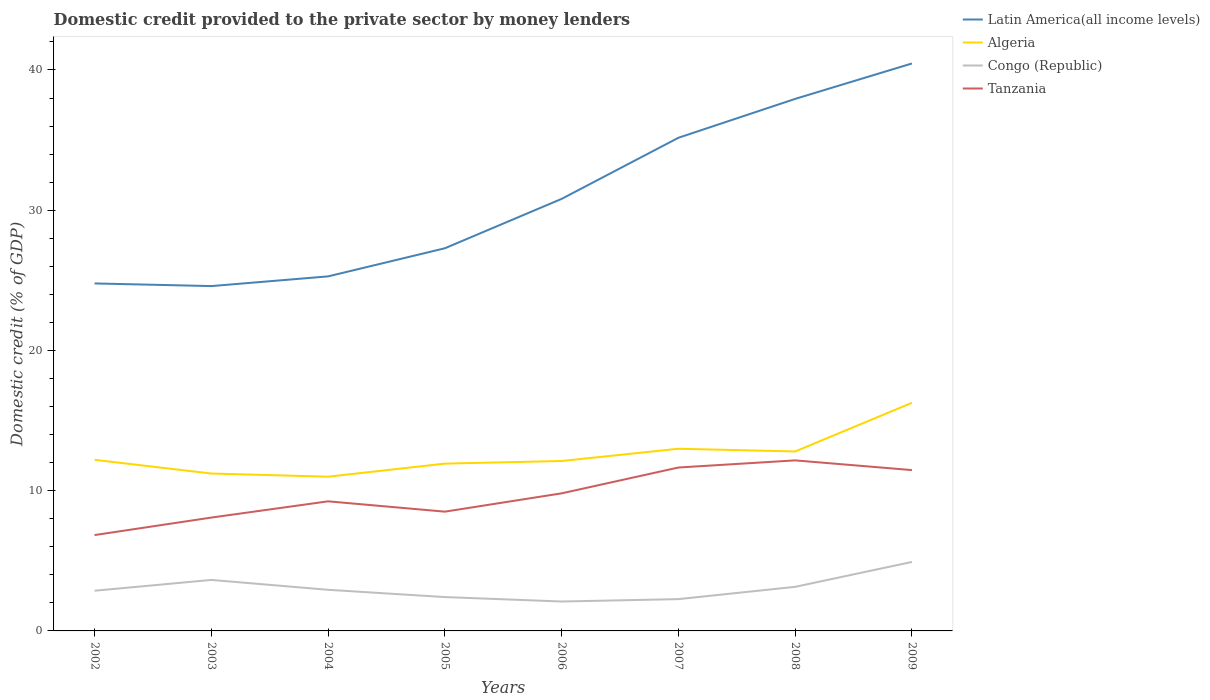Does the line corresponding to Tanzania intersect with the line corresponding to Latin America(all income levels)?
Offer a very short reply. No. Across all years, what is the maximum domestic credit provided to the private sector by money lenders in Congo (Republic)?
Provide a short and direct response. 2.1. In which year was the domestic credit provided to the private sector by money lenders in Tanzania maximum?
Ensure brevity in your answer.  2002. What is the total domestic credit provided to the private sector by money lenders in Latin America(all income levels) in the graph?
Provide a short and direct response. -0.69. What is the difference between the highest and the second highest domestic credit provided to the private sector by money lenders in Congo (Republic)?
Ensure brevity in your answer.  2.82. What is the difference between the highest and the lowest domestic credit provided to the private sector by money lenders in Congo (Republic)?
Offer a very short reply. 3. How many lines are there?
Ensure brevity in your answer.  4. What is the difference between two consecutive major ticks on the Y-axis?
Your answer should be very brief. 10. Does the graph contain any zero values?
Make the answer very short. No. Where does the legend appear in the graph?
Provide a short and direct response. Top right. How many legend labels are there?
Ensure brevity in your answer.  4. How are the legend labels stacked?
Keep it short and to the point. Vertical. What is the title of the graph?
Offer a very short reply. Domestic credit provided to the private sector by money lenders. What is the label or title of the Y-axis?
Provide a short and direct response. Domestic credit (% of GDP). What is the Domestic credit (% of GDP) in Latin America(all income levels) in 2002?
Provide a short and direct response. 24.78. What is the Domestic credit (% of GDP) of Algeria in 2002?
Provide a succinct answer. 12.2. What is the Domestic credit (% of GDP) in Congo (Republic) in 2002?
Offer a terse response. 2.87. What is the Domestic credit (% of GDP) in Tanzania in 2002?
Offer a very short reply. 6.83. What is the Domestic credit (% of GDP) of Latin America(all income levels) in 2003?
Offer a terse response. 24.59. What is the Domestic credit (% of GDP) in Algeria in 2003?
Your answer should be compact. 11.22. What is the Domestic credit (% of GDP) of Congo (Republic) in 2003?
Give a very brief answer. 3.64. What is the Domestic credit (% of GDP) of Tanzania in 2003?
Give a very brief answer. 8.08. What is the Domestic credit (% of GDP) of Latin America(all income levels) in 2004?
Provide a short and direct response. 25.28. What is the Domestic credit (% of GDP) in Algeria in 2004?
Make the answer very short. 11. What is the Domestic credit (% of GDP) of Congo (Republic) in 2004?
Your response must be concise. 2.93. What is the Domestic credit (% of GDP) of Tanzania in 2004?
Your answer should be very brief. 9.24. What is the Domestic credit (% of GDP) in Latin America(all income levels) in 2005?
Offer a very short reply. 27.29. What is the Domestic credit (% of GDP) in Algeria in 2005?
Keep it short and to the point. 11.93. What is the Domestic credit (% of GDP) in Congo (Republic) in 2005?
Your answer should be very brief. 2.41. What is the Domestic credit (% of GDP) of Tanzania in 2005?
Offer a very short reply. 8.5. What is the Domestic credit (% of GDP) of Latin America(all income levels) in 2006?
Give a very brief answer. 30.81. What is the Domestic credit (% of GDP) of Algeria in 2006?
Your answer should be compact. 12.12. What is the Domestic credit (% of GDP) in Congo (Republic) in 2006?
Provide a succinct answer. 2.1. What is the Domestic credit (% of GDP) of Tanzania in 2006?
Give a very brief answer. 9.81. What is the Domestic credit (% of GDP) of Latin America(all income levels) in 2007?
Offer a terse response. 35.16. What is the Domestic credit (% of GDP) in Algeria in 2007?
Offer a very short reply. 12.99. What is the Domestic credit (% of GDP) of Congo (Republic) in 2007?
Offer a terse response. 2.27. What is the Domestic credit (% of GDP) in Tanzania in 2007?
Provide a short and direct response. 11.65. What is the Domestic credit (% of GDP) in Latin America(all income levels) in 2008?
Offer a terse response. 37.94. What is the Domestic credit (% of GDP) of Algeria in 2008?
Offer a terse response. 12.8. What is the Domestic credit (% of GDP) of Congo (Republic) in 2008?
Keep it short and to the point. 3.14. What is the Domestic credit (% of GDP) of Tanzania in 2008?
Make the answer very short. 12.16. What is the Domestic credit (% of GDP) in Latin America(all income levels) in 2009?
Give a very brief answer. 40.46. What is the Domestic credit (% of GDP) in Algeria in 2009?
Give a very brief answer. 16.27. What is the Domestic credit (% of GDP) of Congo (Republic) in 2009?
Your answer should be compact. 4.92. What is the Domestic credit (% of GDP) in Tanzania in 2009?
Your answer should be compact. 11.47. Across all years, what is the maximum Domestic credit (% of GDP) of Latin America(all income levels)?
Ensure brevity in your answer.  40.46. Across all years, what is the maximum Domestic credit (% of GDP) of Algeria?
Your answer should be compact. 16.27. Across all years, what is the maximum Domestic credit (% of GDP) of Congo (Republic)?
Your answer should be compact. 4.92. Across all years, what is the maximum Domestic credit (% of GDP) in Tanzania?
Your answer should be very brief. 12.16. Across all years, what is the minimum Domestic credit (% of GDP) in Latin America(all income levels)?
Your response must be concise. 24.59. Across all years, what is the minimum Domestic credit (% of GDP) of Algeria?
Keep it short and to the point. 11. Across all years, what is the minimum Domestic credit (% of GDP) of Congo (Republic)?
Give a very brief answer. 2.1. Across all years, what is the minimum Domestic credit (% of GDP) of Tanzania?
Provide a succinct answer. 6.83. What is the total Domestic credit (% of GDP) of Latin America(all income levels) in the graph?
Give a very brief answer. 246.3. What is the total Domestic credit (% of GDP) of Algeria in the graph?
Offer a terse response. 100.52. What is the total Domestic credit (% of GDP) of Congo (Republic) in the graph?
Offer a very short reply. 24.28. What is the total Domestic credit (% of GDP) in Tanzania in the graph?
Your response must be concise. 77.75. What is the difference between the Domestic credit (% of GDP) of Latin America(all income levels) in 2002 and that in 2003?
Provide a succinct answer. 0.19. What is the difference between the Domestic credit (% of GDP) in Algeria in 2002 and that in 2003?
Keep it short and to the point. 0.98. What is the difference between the Domestic credit (% of GDP) of Congo (Republic) in 2002 and that in 2003?
Provide a short and direct response. -0.77. What is the difference between the Domestic credit (% of GDP) of Tanzania in 2002 and that in 2003?
Your answer should be very brief. -1.25. What is the difference between the Domestic credit (% of GDP) of Latin America(all income levels) in 2002 and that in 2004?
Provide a succinct answer. -0.5. What is the difference between the Domestic credit (% of GDP) of Algeria in 2002 and that in 2004?
Keep it short and to the point. 1.2. What is the difference between the Domestic credit (% of GDP) of Congo (Republic) in 2002 and that in 2004?
Your answer should be very brief. -0.07. What is the difference between the Domestic credit (% of GDP) in Tanzania in 2002 and that in 2004?
Make the answer very short. -2.41. What is the difference between the Domestic credit (% of GDP) of Latin America(all income levels) in 2002 and that in 2005?
Offer a terse response. -2.51. What is the difference between the Domestic credit (% of GDP) of Algeria in 2002 and that in 2005?
Make the answer very short. 0.27. What is the difference between the Domestic credit (% of GDP) in Congo (Republic) in 2002 and that in 2005?
Ensure brevity in your answer.  0.45. What is the difference between the Domestic credit (% of GDP) of Tanzania in 2002 and that in 2005?
Make the answer very short. -1.67. What is the difference between the Domestic credit (% of GDP) of Latin America(all income levels) in 2002 and that in 2006?
Offer a very short reply. -6.03. What is the difference between the Domestic credit (% of GDP) of Algeria in 2002 and that in 2006?
Provide a succinct answer. 0.08. What is the difference between the Domestic credit (% of GDP) of Congo (Republic) in 2002 and that in 2006?
Make the answer very short. 0.77. What is the difference between the Domestic credit (% of GDP) of Tanzania in 2002 and that in 2006?
Your answer should be compact. -2.98. What is the difference between the Domestic credit (% of GDP) in Latin America(all income levels) in 2002 and that in 2007?
Keep it short and to the point. -10.39. What is the difference between the Domestic credit (% of GDP) of Algeria in 2002 and that in 2007?
Offer a terse response. -0.79. What is the difference between the Domestic credit (% of GDP) of Congo (Republic) in 2002 and that in 2007?
Make the answer very short. 0.6. What is the difference between the Domestic credit (% of GDP) in Tanzania in 2002 and that in 2007?
Provide a succinct answer. -4.82. What is the difference between the Domestic credit (% of GDP) in Latin America(all income levels) in 2002 and that in 2008?
Keep it short and to the point. -13.16. What is the difference between the Domestic credit (% of GDP) of Algeria in 2002 and that in 2008?
Keep it short and to the point. -0.6. What is the difference between the Domestic credit (% of GDP) of Congo (Republic) in 2002 and that in 2008?
Provide a succinct answer. -0.28. What is the difference between the Domestic credit (% of GDP) in Tanzania in 2002 and that in 2008?
Offer a very short reply. -5.33. What is the difference between the Domestic credit (% of GDP) in Latin America(all income levels) in 2002 and that in 2009?
Make the answer very short. -15.68. What is the difference between the Domestic credit (% of GDP) in Algeria in 2002 and that in 2009?
Your answer should be compact. -4.07. What is the difference between the Domestic credit (% of GDP) of Congo (Republic) in 2002 and that in 2009?
Ensure brevity in your answer.  -2.05. What is the difference between the Domestic credit (% of GDP) in Tanzania in 2002 and that in 2009?
Your answer should be very brief. -4.63. What is the difference between the Domestic credit (% of GDP) in Latin America(all income levels) in 2003 and that in 2004?
Offer a terse response. -0.69. What is the difference between the Domestic credit (% of GDP) of Algeria in 2003 and that in 2004?
Offer a terse response. 0.22. What is the difference between the Domestic credit (% of GDP) of Congo (Republic) in 2003 and that in 2004?
Your answer should be very brief. 0.7. What is the difference between the Domestic credit (% of GDP) of Tanzania in 2003 and that in 2004?
Your answer should be very brief. -1.16. What is the difference between the Domestic credit (% of GDP) of Latin America(all income levels) in 2003 and that in 2005?
Keep it short and to the point. -2.7. What is the difference between the Domestic credit (% of GDP) in Algeria in 2003 and that in 2005?
Your answer should be very brief. -0.71. What is the difference between the Domestic credit (% of GDP) of Congo (Republic) in 2003 and that in 2005?
Offer a terse response. 1.22. What is the difference between the Domestic credit (% of GDP) of Tanzania in 2003 and that in 2005?
Keep it short and to the point. -0.42. What is the difference between the Domestic credit (% of GDP) of Latin America(all income levels) in 2003 and that in 2006?
Provide a short and direct response. -6.22. What is the difference between the Domestic credit (% of GDP) in Algeria in 2003 and that in 2006?
Make the answer very short. -0.89. What is the difference between the Domestic credit (% of GDP) in Congo (Republic) in 2003 and that in 2006?
Offer a very short reply. 1.54. What is the difference between the Domestic credit (% of GDP) of Tanzania in 2003 and that in 2006?
Give a very brief answer. -1.73. What is the difference between the Domestic credit (% of GDP) in Latin America(all income levels) in 2003 and that in 2007?
Your answer should be compact. -10.58. What is the difference between the Domestic credit (% of GDP) of Algeria in 2003 and that in 2007?
Your response must be concise. -1.77. What is the difference between the Domestic credit (% of GDP) of Congo (Republic) in 2003 and that in 2007?
Provide a succinct answer. 1.37. What is the difference between the Domestic credit (% of GDP) of Tanzania in 2003 and that in 2007?
Provide a short and direct response. -3.57. What is the difference between the Domestic credit (% of GDP) in Latin America(all income levels) in 2003 and that in 2008?
Your answer should be compact. -13.35. What is the difference between the Domestic credit (% of GDP) in Algeria in 2003 and that in 2008?
Provide a succinct answer. -1.57. What is the difference between the Domestic credit (% of GDP) in Congo (Republic) in 2003 and that in 2008?
Provide a succinct answer. 0.49. What is the difference between the Domestic credit (% of GDP) in Tanzania in 2003 and that in 2008?
Give a very brief answer. -4.08. What is the difference between the Domestic credit (% of GDP) in Latin America(all income levels) in 2003 and that in 2009?
Your answer should be compact. -15.87. What is the difference between the Domestic credit (% of GDP) of Algeria in 2003 and that in 2009?
Give a very brief answer. -5.04. What is the difference between the Domestic credit (% of GDP) of Congo (Republic) in 2003 and that in 2009?
Your answer should be very brief. -1.28. What is the difference between the Domestic credit (% of GDP) in Tanzania in 2003 and that in 2009?
Offer a very short reply. -3.38. What is the difference between the Domestic credit (% of GDP) in Latin America(all income levels) in 2004 and that in 2005?
Provide a succinct answer. -2. What is the difference between the Domestic credit (% of GDP) in Algeria in 2004 and that in 2005?
Your answer should be compact. -0.93. What is the difference between the Domestic credit (% of GDP) of Congo (Republic) in 2004 and that in 2005?
Provide a succinct answer. 0.52. What is the difference between the Domestic credit (% of GDP) of Tanzania in 2004 and that in 2005?
Provide a short and direct response. 0.74. What is the difference between the Domestic credit (% of GDP) in Latin America(all income levels) in 2004 and that in 2006?
Keep it short and to the point. -5.53. What is the difference between the Domestic credit (% of GDP) in Algeria in 2004 and that in 2006?
Offer a terse response. -1.12. What is the difference between the Domestic credit (% of GDP) of Congo (Republic) in 2004 and that in 2006?
Make the answer very short. 0.84. What is the difference between the Domestic credit (% of GDP) of Tanzania in 2004 and that in 2006?
Ensure brevity in your answer.  -0.57. What is the difference between the Domestic credit (% of GDP) of Latin America(all income levels) in 2004 and that in 2007?
Offer a terse response. -9.88. What is the difference between the Domestic credit (% of GDP) in Algeria in 2004 and that in 2007?
Your response must be concise. -1.99. What is the difference between the Domestic credit (% of GDP) in Congo (Republic) in 2004 and that in 2007?
Offer a terse response. 0.67. What is the difference between the Domestic credit (% of GDP) of Tanzania in 2004 and that in 2007?
Your response must be concise. -2.41. What is the difference between the Domestic credit (% of GDP) of Latin America(all income levels) in 2004 and that in 2008?
Give a very brief answer. -12.66. What is the difference between the Domestic credit (% of GDP) of Algeria in 2004 and that in 2008?
Offer a terse response. -1.8. What is the difference between the Domestic credit (% of GDP) of Congo (Republic) in 2004 and that in 2008?
Offer a terse response. -0.21. What is the difference between the Domestic credit (% of GDP) in Tanzania in 2004 and that in 2008?
Make the answer very short. -2.92. What is the difference between the Domestic credit (% of GDP) in Latin America(all income levels) in 2004 and that in 2009?
Your answer should be compact. -15.18. What is the difference between the Domestic credit (% of GDP) in Algeria in 2004 and that in 2009?
Offer a very short reply. -5.27. What is the difference between the Domestic credit (% of GDP) in Congo (Republic) in 2004 and that in 2009?
Provide a succinct answer. -1.99. What is the difference between the Domestic credit (% of GDP) of Tanzania in 2004 and that in 2009?
Provide a succinct answer. -2.23. What is the difference between the Domestic credit (% of GDP) of Latin America(all income levels) in 2005 and that in 2006?
Your response must be concise. -3.52. What is the difference between the Domestic credit (% of GDP) in Algeria in 2005 and that in 2006?
Give a very brief answer. -0.19. What is the difference between the Domestic credit (% of GDP) in Congo (Republic) in 2005 and that in 2006?
Provide a succinct answer. 0.32. What is the difference between the Domestic credit (% of GDP) in Tanzania in 2005 and that in 2006?
Provide a short and direct response. -1.31. What is the difference between the Domestic credit (% of GDP) in Latin America(all income levels) in 2005 and that in 2007?
Make the answer very short. -7.88. What is the difference between the Domestic credit (% of GDP) of Algeria in 2005 and that in 2007?
Offer a very short reply. -1.06. What is the difference between the Domestic credit (% of GDP) of Congo (Republic) in 2005 and that in 2007?
Your response must be concise. 0.15. What is the difference between the Domestic credit (% of GDP) in Tanzania in 2005 and that in 2007?
Provide a short and direct response. -3.15. What is the difference between the Domestic credit (% of GDP) of Latin America(all income levels) in 2005 and that in 2008?
Keep it short and to the point. -10.65. What is the difference between the Domestic credit (% of GDP) in Algeria in 2005 and that in 2008?
Offer a terse response. -0.87. What is the difference between the Domestic credit (% of GDP) in Congo (Republic) in 2005 and that in 2008?
Offer a very short reply. -0.73. What is the difference between the Domestic credit (% of GDP) of Tanzania in 2005 and that in 2008?
Your response must be concise. -3.66. What is the difference between the Domestic credit (% of GDP) of Latin America(all income levels) in 2005 and that in 2009?
Give a very brief answer. -13.18. What is the difference between the Domestic credit (% of GDP) in Algeria in 2005 and that in 2009?
Your response must be concise. -4.34. What is the difference between the Domestic credit (% of GDP) of Congo (Republic) in 2005 and that in 2009?
Your answer should be very brief. -2.5. What is the difference between the Domestic credit (% of GDP) in Tanzania in 2005 and that in 2009?
Provide a short and direct response. -2.96. What is the difference between the Domestic credit (% of GDP) in Latin America(all income levels) in 2006 and that in 2007?
Your answer should be very brief. -4.36. What is the difference between the Domestic credit (% of GDP) of Algeria in 2006 and that in 2007?
Provide a succinct answer. -0.87. What is the difference between the Domestic credit (% of GDP) of Congo (Republic) in 2006 and that in 2007?
Make the answer very short. -0.17. What is the difference between the Domestic credit (% of GDP) of Tanzania in 2006 and that in 2007?
Offer a very short reply. -1.84. What is the difference between the Domestic credit (% of GDP) of Latin America(all income levels) in 2006 and that in 2008?
Offer a terse response. -7.13. What is the difference between the Domestic credit (% of GDP) of Algeria in 2006 and that in 2008?
Give a very brief answer. -0.68. What is the difference between the Domestic credit (% of GDP) of Congo (Republic) in 2006 and that in 2008?
Give a very brief answer. -1.05. What is the difference between the Domestic credit (% of GDP) in Tanzania in 2006 and that in 2008?
Provide a succinct answer. -2.35. What is the difference between the Domestic credit (% of GDP) in Latin America(all income levels) in 2006 and that in 2009?
Give a very brief answer. -9.65. What is the difference between the Domestic credit (% of GDP) in Algeria in 2006 and that in 2009?
Your response must be concise. -4.15. What is the difference between the Domestic credit (% of GDP) of Congo (Republic) in 2006 and that in 2009?
Offer a very short reply. -2.82. What is the difference between the Domestic credit (% of GDP) of Tanzania in 2006 and that in 2009?
Keep it short and to the point. -1.66. What is the difference between the Domestic credit (% of GDP) in Latin America(all income levels) in 2007 and that in 2008?
Your answer should be very brief. -2.77. What is the difference between the Domestic credit (% of GDP) in Algeria in 2007 and that in 2008?
Offer a very short reply. 0.19. What is the difference between the Domestic credit (% of GDP) of Congo (Republic) in 2007 and that in 2008?
Your answer should be compact. -0.88. What is the difference between the Domestic credit (% of GDP) of Tanzania in 2007 and that in 2008?
Your answer should be compact. -0.51. What is the difference between the Domestic credit (% of GDP) in Latin America(all income levels) in 2007 and that in 2009?
Keep it short and to the point. -5.3. What is the difference between the Domestic credit (% of GDP) in Algeria in 2007 and that in 2009?
Offer a very short reply. -3.28. What is the difference between the Domestic credit (% of GDP) in Congo (Republic) in 2007 and that in 2009?
Your response must be concise. -2.65. What is the difference between the Domestic credit (% of GDP) of Tanzania in 2007 and that in 2009?
Offer a very short reply. 0.18. What is the difference between the Domestic credit (% of GDP) of Latin America(all income levels) in 2008 and that in 2009?
Your answer should be very brief. -2.53. What is the difference between the Domestic credit (% of GDP) of Algeria in 2008 and that in 2009?
Offer a terse response. -3.47. What is the difference between the Domestic credit (% of GDP) of Congo (Republic) in 2008 and that in 2009?
Offer a very short reply. -1.77. What is the difference between the Domestic credit (% of GDP) in Tanzania in 2008 and that in 2009?
Ensure brevity in your answer.  0.69. What is the difference between the Domestic credit (% of GDP) of Latin America(all income levels) in 2002 and the Domestic credit (% of GDP) of Algeria in 2003?
Provide a short and direct response. 13.55. What is the difference between the Domestic credit (% of GDP) in Latin America(all income levels) in 2002 and the Domestic credit (% of GDP) in Congo (Republic) in 2003?
Provide a succinct answer. 21.14. What is the difference between the Domestic credit (% of GDP) of Latin America(all income levels) in 2002 and the Domestic credit (% of GDP) of Tanzania in 2003?
Your answer should be very brief. 16.69. What is the difference between the Domestic credit (% of GDP) in Algeria in 2002 and the Domestic credit (% of GDP) in Congo (Republic) in 2003?
Your response must be concise. 8.56. What is the difference between the Domestic credit (% of GDP) in Algeria in 2002 and the Domestic credit (% of GDP) in Tanzania in 2003?
Provide a short and direct response. 4.12. What is the difference between the Domestic credit (% of GDP) of Congo (Republic) in 2002 and the Domestic credit (% of GDP) of Tanzania in 2003?
Your response must be concise. -5.22. What is the difference between the Domestic credit (% of GDP) of Latin America(all income levels) in 2002 and the Domestic credit (% of GDP) of Algeria in 2004?
Make the answer very short. 13.78. What is the difference between the Domestic credit (% of GDP) of Latin America(all income levels) in 2002 and the Domestic credit (% of GDP) of Congo (Republic) in 2004?
Ensure brevity in your answer.  21.84. What is the difference between the Domestic credit (% of GDP) of Latin America(all income levels) in 2002 and the Domestic credit (% of GDP) of Tanzania in 2004?
Your answer should be very brief. 15.54. What is the difference between the Domestic credit (% of GDP) in Algeria in 2002 and the Domestic credit (% of GDP) in Congo (Republic) in 2004?
Give a very brief answer. 9.27. What is the difference between the Domestic credit (% of GDP) in Algeria in 2002 and the Domestic credit (% of GDP) in Tanzania in 2004?
Offer a terse response. 2.96. What is the difference between the Domestic credit (% of GDP) in Congo (Republic) in 2002 and the Domestic credit (% of GDP) in Tanzania in 2004?
Offer a terse response. -6.37. What is the difference between the Domestic credit (% of GDP) of Latin America(all income levels) in 2002 and the Domestic credit (% of GDP) of Algeria in 2005?
Provide a short and direct response. 12.85. What is the difference between the Domestic credit (% of GDP) in Latin America(all income levels) in 2002 and the Domestic credit (% of GDP) in Congo (Republic) in 2005?
Make the answer very short. 22.36. What is the difference between the Domestic credit (% of GDP) in Latin America(all income levels) in 2002 and the Domestic credit (% of GDP) in Tanzania in 2005?
Make the answer very short. 16.27. What is the difference between the Domestic credit (% of GDP) in Algeria in 2002 and the Domestic credit (% of GDP) in Congo (Republic) in 2005?
Ensure brevity in your answer.  9.79. What is the difference between the Domestic credit (% of GDP) in Algeria in 2002 and the Domestic credit (% of GDP) in Tanzania in 2005?
Make the answer very short. 3.7. What is the difference between the Domestic credit (% of GDP) in Congo (Republic) in 2002 and the Domestic credit (% of GDP) in Tanzania in 2005?
Provide a succinct answer. -5.64. What is the difference between the Domestic credit (% of GDP) in Latin America(all income levels) in 2002 and the Domestic credit (% of GDP) in Algeria in 2006?
Provide a succinct answer. 12.66. What is the difference between the Domestic credit (% of GDP) of Latin America(all income levels) in 2002 and the Domestic credit (% of GDP) of Congo (Republic) in 2006?
Ensure brevity in your answer.  22.68. What is the difference between the Domestic credit (% of GDP) in Latin America(all income levels) in 2002 and the Domestic credit (% of GDP) in Tanzania in 2006?
Provide a short and direct response. 14.97. What is the difference between the Domestic credit (% of GDP) of Algeria in 2002 and the Domestic credit (% of GDP) of Congo (Republic) in 2006?
Provide a succinct answer. 10.1. What is the difference between the Domestic credit (% of GDP) of Algeria in 2002 and the Domestic credit (% of GDP) of Tanzania in 2006?
Your answer should be very brief. 2.39. What is the difference between the Domestic credit (% of GDP) of Congo (Republic) in 2002 and the Domestic credit (% of GDP) of Tanzania in 2006?
Give a very brief answer. -6.94. What is the difference between the Domestic credit (% of GDP) in Latin America(all income levels) in 2002 and the Domestic credit (% of GDP) in Algeria in 2007?
Provide a short and direct response. 11.79. What is the difference between the Domestic credit (% of GDP) in Latin America(all income levels) in 2002 and the Domestic credit (% of GDP) in Congo (Republic) in 2007?
Keep it short and to the point. 22.51. What is the difference between the Domestic credit (% of GDP) of Latin America(all income levels) in 2002 and the Domestic credit (% of GDP) of Tanzania in 2007?
Your answer should be very brief. 13.13. What is the difference between the Domestic credit (% of GDP) of Algeria in 2002 and the Domestic credit (% of GDP) of Congo (Republic) in 2007?
Provide a succinct answer. 9.93. What is the difference between the Domestic credit (% of GDP) in Algeria in 2002 and the Domestic credit (% of GDP) in Tanzania in 2007?
Provide a short and direct response. 0.55. What is the difference between the Domestic credit (% of GDP) of Congo (Republic) in 2002 and the Domestic credit (% of GDP) of Tanzania in 2007?
Offer a terse response. -8.79. What is the difference between the Domestic credit (% of GDP) in Latin America(all income levels) in 2002 and the Domestic credit (% of GDP) in Algeria in 2008?
Provide a succinct answer. 11.98. What is the difference between the Domestic credit (% of GDP) of Latin America(all income levels) in 2002 and the Domestic credit (% of GDP) of Congo (Republic) in 2008?
Your response must be concise. 21.63. What is the difference between the Domestic credit (% of GDP) of Latin America(all income levels) in 2002 and the Domestic credit (% of GDP) of Tanzania in 2008?
Ensure brevity in your answer.  12.62. What is the difference between the Domestic credit (% of GDP) in Algeria in 2002 and the Domestic credit (% of GDP) in Congo (Republic) in 2008?
Your answer should be compact. 9.06. What is the difference between the Domestic credit (% of GDP) in Algeria in 2002 and the Domestic credit (% of GDP) in Tanzania in 2008?
Offer a terse response. 0.04. What is the difference between the Domestic credit (% of GDP) of Congo (Republic) in 2002 and the Domestic credit (% of GDP) of Tanzania in 2008?
Offer a terse response. -9.29. What is the difference between the Domestic credit (% of GDP) in Latin America(all income levels) in 2002 and the Domestic credit (% of GDP) in Algeria in 2009?
Your answer should be very brief. 8.51. What is the difference between the Domestic credit (% of GDP) in Latin America(all income levels) in 2002 and the Domestic credit (% of GDP) in Congo (Republic) in 2009?
Offer a terse response. 19.86. What is the difference between the Domestic credit (% of GDP) in Latin America(all income levels) in 2002 and the Domestic credit (% of GDP) in Tanzania in 2009?
Offer a terse response. 13.31. What is the difference between the Domestic credit (% of GDP) of Algeria in 2002 and the Domestic credit (% of GDP) of Congo (Republic) in 2009?
Ensure brevity in your answer.  7.28. What is the difference between the Domestic credit (% of GDP) of Algeria in 2002 and the Domestic credit (% of GDP) of Tanzania in 2009?
Make the answer very short. 0.73. What is the difference between the Domestic credit (% of GDP) of Congo (Republic) in 2002 and the Domestic credit (% of GDP) of Tanzania in 2009?
Provide a succinct answer. -8.6. What is the difference between the Domestic credit (% of GDP) of Latin America(all income levels) in 2003 and the Domestic credit (% of GDP) of Algeria in 2004?
Make the answer very short. 13.59. What is the difference between the Domestic credit (% of GDP) in Latin America(all income levels) in 2003 and the Domestic credit (% of GDP) in Congo (Republic) in 2004?
Keep it short and to the point. 21.66. What is the difference between the Domestic credit (% of GDP) of Latin America(all income levels) in 2003 and the Domestic credit (% of GDP) of Tanzania in 2004?
Offer a very short reply. 15.35. What is the difference between the Domestic credit (% of GDP) in Algeria in 2003 and the Domestic credit (% of GDP) in Congo (Republic) in 2004?
Offer a very short reply. 8.29. What is the difference between the Domestic credit (% of GDP) of Algeria in 2003 and the Domestic credit (% of GDP) of Tanzania in 2004?
Your answer should be very brief. 1.98. What is the difference between the Domestic credit (% of GDP) in Congo (Republic) in 2003 and the Domestic credit (% of GDP) in Tanzania in 2004?
Your response must be concise. -5.6. What is the difference between the Domestic credit (% of GDP) in Latin America(all income levels) in 2003 and the Domestic credit (% of GDP) in Algeria in 2005?
Give a very brief answer. 12.66. What is the difference between the Domestic credit (% of GDP) of Latin America(all income levels) in 2003 and the Domestic credit (% of GDP) of Congo (Republic) in 2005?
Your response must be concise. 22.17. What is the difference between the Domestic credit (% of GDP) in Latin America(all income levels) in 2003 and the Domestic credit (% of GDP) in Tanzania in 2005?
Provide a succinct answer. 16.08. What is the difference between the Domestic credit (% of GDP) of Algeria in 2003 and the Domestic credit (% of GDP) of Congo (Republic) in 2005?
Your answer should be compact. 8.81. What is the difference between the Domestic credit (% of GDP) in Algeria in 2003 and the Domestic credit (% of GDP) in Tanzania in 2005?
Provide a succinct answer. 2.72. What is the difference between the Domestic credit (% of GDP) in Congo (Republic) in 2003 and the Domestic credit (% of GDP) in Tanzania in 2005?
Keep it short and to the point. -4.87. What is the difference between the Domestic credit (% of GDP) in Latin America(all income levels) in 2003 and the Domestic credit (% of GDP) in Algeria in 2006?
Keep it short and to the point. 12.47. What is the difference between the Domestic credit (% of GDP) of Latin America(all income levels) in 2003 and the Domestic credit (% of GDP) of Congo (Republic) in 2006?
Provide a succinct answer. 22.49. What is the difference between the Domestic credit (% of GDP) in Latin America(all income levels) in 2003 and the Domestic credit (% of GDP) in Tanzania in 2006?
Keep it short and to the point. 14.78. What is the difference between the Domestic credit (% of GDP) of Algeria in 2003 and the Domestic credit (% of GDP) of Congo (Republic) in 2006?
Provide a short and direct response. 9.13. What is the difference between the Domestic credit (% of GDP) in Algeria in 2003 and the Domestic credit (% of GDP) in Tanzania in 2006?
Make the answer very short. 1.41. What is the difference between the Domestic credit (% of GDP) in Congo (Republic) in 2003 and the Domestic credit (% of GDP) in Tanzania in 2006?
Your response must be concise. -6.17. What is the difference between the Domestic credit (% of GDP) in Latin America(all income levels) in 2003 and the Domestic credit (% of GDP) in Algeria in 2007?
Offer a terse response. 11.6. What is the difference between the Domestic credit (% of GDP) in Latin America(all income levels) in 2003 and the Domestic credit (% of GDP) in Congo (Republic) in 2007?
Provide a short and direct response. 22.32. What is the difference between the Domestic credit (% of GDP) in Latin America(all income levels) in 2003 and the Domestic credit (% of GDP) in Tanzania in 2007?
Offer a terse response. 12.94. What is the difference between the Domestic credit (% of GDP) of Algeria in 2003 and the Domestic credit (% of GDP) of Congo (Republic) in 2007?
Keep it short and to the point. 8.96. What is the difference between the Domestic credit (% of GDP) in Algeria in 2003 and the Domestic credit (% of GDP) in Tanzania in 2007?
Provide a short and direct response. -0.43. What is the difference between the Domestic credit (% of GDP) in Congo (Republic) in 2003 and the Domestic credit (% of GDP) in Tanzania in 2007?
Your answer should be compact. -8.02. What is the difference between the Domestic credit (% of GDP) of Latin America(all income levels) in 2003 and the Domestic credit (% of GDP) of Algeria in 2008?
Your answer should be very brief. 11.79. What is the difference between the Domestic credit (% of GDP) of Latin America(all income levels) in 2003 and the Domestic credit (% of GDP) of Congo (Republic) in 2008?
Your response must be concise. 21.44. What is the difference between the Domestic credit (% of GDP) in Latin America(all income levels) in 2003 and the Domestic credit (% of GDP) in Tanzania in 2008?
Make the answer very short. 12.43. What is the difference between the Domestic credit (% of GDP) of Algeria in 2003 and the Domestic credit (% of GDP) of Congo (Republic) in 2008?
Offer a terse response. 8.08. What is the difference between the Domestic credit (% of GDP) of Algeria in 2003 and the Domestic credit (% of GDP) of Tanzania in 2008?
Provide a succinct answer. -0.94. What is the difference between the Domestic credit (% of GDP) in Congo (Republic) in 2003 and the Domestic credit (% of GDP) in Tanzania in 2008?
Provide a short and direct response. -8.52. What is the difference between the Domestic credit (% of GDP) in Latin America(all income levels) in 2003 and the Domestic credit (% of GDP) in Algeria in 2009?
Offer a very short reply. 8.32. What is the difference between the Domestic credit (% of GDP) in Latin America(all income levels) in 2003 and the Domestic credit (% of GDP) in Congo (Republic) in 2009?
Your response must be concise. 19.67. What is the difference between the Domestic credit (% of GDP) in Latin America(all income levels) in 2003 and the Domestic credit (% of GDP) in Tanzania in 2009?
Keep it short and to the point. 13.12. What is the difference between the Domestic credit (% of GDP) of Algeria in 2003 and the Domestic credit (% of GDP) of Congo (Republic) in 2009?
Make the answer very short. 6.3. What is the difference between the Domestic credit (% of GDP) in Algeria in 2003 and the Domestic credit (% of GDP) in Tanzania in 2009?
Provide a short and direct response. -0.25. What is the difference between the Domestic credit (% of GDP) of Congo (Republic) in 2003 and the Domestic credit (% of GDP) of Tanzania in 2009?
Your response must be concise. -7.83. What is the difference between the Domestic credit (% of GDP) in Latin America(all income levels) in 2004 and the Domestic credit (% of GDP) in Algeria in 2005?
Offer a very short reply. 13.35. What is the difference between the Domestic credit (% of GDP) of Latin America(all income levels) in 2004 and the Domestic credit (% of GDP) of Congo (Republic) in 2005?
Make the answer very short. 22.87. What is the difference between the Domestic credit (% of GDP) of Latin America(all income levels) in 2004 and the Domestic credit (% of GDP) of Tanzania in 2005?
Give a very brief answer. 16.78. What is the difference between the Domestic credit (% of GDP) of Algeria in 2004 and the Domestic credit (% of GDP) of Congo (Republic) in 2005?
Your answer should be very brief. 8.58. What is the difference between the Domestic credit (% of GDP) of Algeria in 2004 and the Domestic credit (% of GDP) of Tanzania in 2005?
Your response must be concise. 2.49. What is the difference between the Domestic credit (% of GDP) of Congo (Republic) in 2004 and the Domestic credit (% of GDP) of Tanzania in 2005?
Ensure brevity in your answer.  -5.57. What is the difference between the Domestic credit (% of GDP) in Latin America(all income levels) in 2004 and the Domestic credit (% of GDP) in Algeria in 2006?
Ensure brevity in your answer.  13.16. What is the difference between the Domestic credit (% of GDP) of Latin America(all income levels) in 2004 and the Domestic credit (% of GDP) of Congo (Republic) in 2006?
Provide a short and direct response. 23.18. What is the difference between the Domestic credit (% of GDP) of Latin America(all income levels) in 2004 and the Domestic credit (% of GDP) of Tanzania in 2006?
Keep it short and to the point. 15.47. What is the difference between the Domestic credit (% of GDP) in Algeria in 2004 and the Domestic credit (% of GDP) in Congo (Republic) in 2006?
Make the answer very short. 8.9. What is the difference between the Domestic credit (% of GDP) of Algeria in 2004 and the Domestic credit (% of GDP) of Tanzania in 2006?
Provide a short and direct response. 1.19. What is the difference between the Domestic credit (% of GDP) in Congo (Republic) in 2004 and the Domestic credit (% of GDP) in Tanzania in 2006?
Provide a succinct answer. -6.88. What is the difference between the Domestic credit (% of GDP) of Latin America(all income levels) in 2004 and the Domestic credit (% of GDP) of Algeria in 2007?
Your answer should be compact. 12.29. What is the difference between the Domestic credit (% of GDP) of Latin America(all income levels) in 2004 and the Domestic credit (% of GDP) of Congo (Republic) in 2007?
Ensure brevity in your answer.  23.01. What is the difference between the Domestic credit (% of GDP) in Latin America(all income levels) in 2004 and the Domestic credit (% of GDP) in Tanzania in 2007?
Keep it short and to the point. 13.63. What is the difference between the Domestic credit (% of GDP) of Algeria in 2004 and the Domestic credit (% of GDP) of Congo (Republic) in 2007?
Offer a very short reply. 8.73. What is the difference between the Domestic credit (% of GDP) of Algeria in 2004 and the Domestic credit (% of GDP) of Tanzania in 2007?
Give a very brief answer. -0.65. What is the difference between the Domestic credit (% of GDP) of Congo (Republic) in 2004 and the Domestic credit (% of GDP) of Tanzania in 2007?
Provide a short and direct response. -8.72. What is the difference between the Domestic credit (% of GDP) in Latin America(all income levels) in 2004 and the Domestic credit (% of GDP) in Algeria in 2008?
Your answer should be very brief. 12.49. What is the difference between the Domestic credit (% of GDP) in Latin America(all income levels) in 2004 and the Domestic credit (% of GDP) in Congo (Republic) in 2008?
Your answer should be very brief. 22.14. What is the difference between the Domestic credit (% of GDP) in Latin America(all income levels) in 2004 and the Domestic credit (% of GDP) in Tanzania in 2008?
Keep it short and to the point. 13.12. What is the difference between the Domestic credit (% of GDP) in Algeria in 2004 and the Domestic credit (% of GDP) in Congo (Republic) in 2008?
Keep it short and to the point. 7.85. What is the difference between the Domestic credit (% of GDP) of Algeria in 2004 and the Domestic credit (% of GDP) of Tanzania in 2008?
Offer a terse response. -1.16. What is the difference between the Domestic credit (% of GDP) of Congo (Republic) in 2004 and the Domestic credit (% of GDP) of Tanzania in 2008?
Offer a very short reply. -9.23. What is the difference between the Domestic credit (% of GDP) in Latin America(all income levels) in 2004 and the Domestic credit (% of GDP) in Algeria in 2009?
Offer a terse response. 9.02. What is the difference between the Domestic credit (% of GDP) of Latin America(all income levels) in 2004 and the Domestic credit (% of GDP) of Congo (Republic) in 2009?
Ensure brevity in your answer.  20.36. What is the difference between the Domestic credit (% of GDP) in Latin America(all income levels) in 2004 and the Domestic credit (% of GDP) in Tanzania in 2009?
Give a very brief answer. 13.81. What is the difference between the Domestic credit (% of GDP) in Algeria in 2004 and the Domestic credit (% of GDP) in Congo (Republic) in 2009?
Your answer should be very brief. 6.08. What is the difference between the Domestic credit (% of GDP) in Algeria in 2004 and the Domestic credit (% of GDP) in Tanzania in 2009?
Give a very brief answer. -0.47. What is the difference between the Domestic credit (% of GDP) in Congo (Republic) in 2004 and the Domestic credit (% of GDP) in Tanzania in 2009?
Give a very brief answer. -8.53. What is the difference between the Domestic credit (% of GDP) of Latin America(all income levels) in 2005 and the Domestic credit (% of GDP) of Algeria in 2006?
Ensure brevity in your answer.  15.17. What is the difference between the Domestic credit (% of GDP) in Latin America(all income levels) in 2005 and the Domestic credit (% of GDP) in Congo (Republic) in 2006?
Your response must be concise. 25.19. What is the difference between the Domestic credit (% of GDP) of Latin America(all income levels) in 2005 and the Domestic credit (% of GDP) of Tanzania in 2006?
Your response must be concise. 17.47. What is the difference between the Domestic credit (% of GDP) in Algeria in 2005 and the Domestic credit (% of GDP) in Congo (Republic) in 2006?
Make the answer very short. 9.83. What is the difference between the Domestic credit (% of GDP) in Algeria in 2005 and the Domestic credit (% of GDP) in Tanzania in 2006?
Offer a very short reply. 2.12. What is the difference between the Domestic credit (% of GDP) of Congo (Republic) in 2005 and the Domestic credit (% of GDP) of Tanzania in 2006?
Give a very brief answer. -7.4. What is the difference between the Domestic credit (% of GDP) of Latin America(all income levels) in 2005 and the Domestic credit (% of GDP) of Algeria in 2007?
Keep it short and to the point. 14.3. What is the difference between the Domestic credit (% of GDP) in Latin America(all income levels) in 2005 and the Domestic credit (% of GDP) in Congo (Republic) in 2007?
Provide a succinct answer. 25.02. What is the difference between the Domestic credit (% of GDP) of Latin America(all income levels) in 2005 and the Domestic credit (% of GDP) of Tanzania in 2007?
Your answer should be very brief. 15.63. What is the difference between the Domestic credit (% of GDP) in Algeria in 2005 and the Domestic credit (% of GDP) in Congo (Republic) in 2007?
Your response must be concise. 9.66. What is the difference between the Domestic credit (% of GDP) of Algeria in 2005 and the Domestic credit (% of GDP) of Tanzania in 2007?
Keep it short and to the point. 0.28. What is the difference between the Domestic credit (% of GDP) in Congo (Republic) in 2005 and the Domestic credit (% of GDP) in Tanzania in 2007?
Provide a succinct answer. -9.24. What is the difference between the Domestic credit (% of GDP) of Latin America(all income levels) in 2005 and the Domestic credit (% of GDP) of Algeria in 2008?
Your answer should be compact. 14.49. What is the difference between the Domestic credit (% of GDP) in Latin America(all income levels) in 2005 and the Domestic credit (% of GDP) in Congo (Republic) in 2008?
Offer a very short reply. 24.14. What is the difference between the Domestic credit (% of GDP) of Latin America(all income levels) in 2005 and the Domestic credit (% of GDP) of Tanzania in 2008?
Provide a succinct answer. 15.12. What is the difference between the Domestic credit (% of GDP) in Algeria in 2005 and the Domestic credit (% of GDP) in Congo (Republic) in 2008?
Offer a terse response. 8.79. What is the difference between the Domestic credit (% of GDP) of Algeria in 2005 and the Domestic credit (% of GDP) of Tanzania in 2008?
Ensure brevity in your answer.  -0.23. What is the difference between the Domestic credit (% of GDP) in Congo (Republic) in 2005 and the Domestic credit (% of GDP) in Tanzania in 2008?
Your answer should be compact. -9.75. What is the difference between the Domestic credit (% of GDP) of Latin America(all income levels) in 2005 and the Domestic credit (% of GDP) of Algeria in 2009?
Offer a very short reply. 11.02. What is the difference between the Domestic credit (% of GDP) of Latin America(all income levels) in 2005 and the Domestic credit (% of GDP) of Congo (Republic) in 2009?
Your answer should be very brief. 22.37. What is the difference between the Domestic credit (% of GDP) in Latin America(all income levels) in 2005 and the Domestic credit (% of GDP) in Tanzania in 2009?
Your response must be concise. 15.82. What is the difference between the Domestic credit (% of GDP) in Algeria in 2005 and the Domestic credit (% of GDP) in Congo (Republic) in 2009?
Your answer should be compact. 7.01. What is the difference between the Domestic credit (% of GDP) of Algeria in 2005 and the Domestic credit (% of GDP) of Tanzania in 2009?
Make the answer very short. 0.46. What is the difference between the Domestic credit (% of GDP) of Congo (Republic) in 2005 and the Domestic credit (% of GDP) of Tanzania in 2009?
Make the answer very short. -9.05. What is the difference between the Domestic credit (% of GDP) of Latin America(all income levels) in 2006 and the Domestic credit (% of GDP) of Algeria in 2007?
Keep it short and to the point. 17.82. What is the difference between the Domestic credit (% of GDP) of Latin America(all income levels) in 2006 and the Domestic credit (% of GDP) of Congo (Republic) in 2007?
Make the answer very short. 28.54. What is the difference between the Domestic credit (% of GDP) of Latin America(all income levels) in 2006 and the Domestic credit (% of GDP) of Tanzania in 2007?
Offer a very short reply. 19.16. What is the difference between the Domestic credit (% of GDP) in Algeria in 2006 and the Domestic credit (% of GDP) in Congo (Republic) in 2007?
Keep it short and to the point. 9.85. What is the difference between the Domestic credit (% of GDP) of Algeria in 2006 and the Domestic credit (% of GDP) of Tanzania in 2007?
Offer a terse response. 0.47. What is the difference between the Domestic credit (% of GDP) of Congo (Republic) in 2006 and the Domestic credit (% of GDP) of Tanzania in 2007?
Provide a short and direct response. -9.55. What is the difference between the Domestic credit (% of GDP) in Latin America(all income levels) in 2006 and the Domestic credit (% of GDP) in Algeria in 2008?
Provide a succinct answer. 18.01. What is the difference between the Domestic credit (% of GDP) of Latin America(all income levels) in 2006 and the Domestic credit (% of GDP) of Congo (Republic) in 2008?
Your response must be concise. 27.66. What is the difference between the Domestic credit (% of GDP) in Latin America(all income levels) in 2006 and the Domestic credit (% of GDP) in Tanzania in 2008?
Make the answer very short. 18.65. What is the difference between the Domestic credit (% of GDP) of Algeria in 2006 and the Domestic credit (% of GDP) of Congo (Republic) in 2008?
Keep it short and to the point. 8.97. What is the difference between the Domestic credit (% of GDP) of Algeria in 2006 and the Domestic credit (% of GDP) of Tanzania in 2008?
Ensure brevity in your answer.  -0.04. What is the difference between the Domestic credit (% of GDP) in Congo (Republic) in 2006 and the Domestic credit (% of GDP) in Tanzania in 2008?
Your response must be concise. -10.06. What is the difference between the Domestic credit (% of GDP) in Latin America(all income levels) in 2006 and the Domestic credit (% of GDP) in Algeria in 2009?
Your response must be concise. 14.54. What is the difference between the Domestic credit (% of GDP) of Latin America(all income levels) in 2006 and the Domestic credit (% of GDP) of Congo (Republic) in 2009?
Your response must be concise. 25.89. What is the difference between the Domestic credit (% of GDP) of Latin America(all income levels) in 2006 and the Domestic credit (% of GDP) of Tanzania in 2009?
Give a very brief answer. 19.34. What is the difference between the Domestic credit (% of GDP) in Algeria in 2006 and the Domestic credit (% of GDP) in Congo (Republic) in 2009?
Ensure brevity in your answer.  7.2. What is the difference between the Domestic credit (% of GDP) of Algeria in 2006 and the Domestic credit (% of GDP) of Tanzania in 2009?
Your response must be concise. 0.65. What is the difference between the Domestic credit (% of GDP) of Congo (Republic) in 2006 and the Domestic credit (% of GDP) of Tanzania in 2009?
Ensure brevity in your answer.  -9.37. What is the difference between the Domestic credit (% of GDP) in Latin America(all income levels) in 2007 and the Domestic credit (% of GDP) in Algeria in 2008?
Your answer should be very brief. 22.37. What is the difference between the Domestic credit (% of GDP) of Latin America(all income levels) in 2007 and the Domestic credit (% of GDP) of Congo (Republic) in 2008?
Give a very brief answer. 32.02. What is the difference between the Domestic credit (% of GDP) of Latin America(all income levels) in 2007 and the Domestic credit (% of GDP) of Tanzania in 2008?
Your response must be concise. 23. What is the difference between the Domestic credit (% of GDP) of Algeria in 2007 and the Domestic credit (% of GDP) of Congo (Republic) in 2008?
Keep it short and to the point. 9.85. What is the difference between the Domestic credit (% of GDP) of Algeria in 2007 and the Domestic credit (% of GDP) of Tanzania in 2008?
Your answer should be compact. 0.83. What is the difference between the Domestic credit (% of GDP) of Congo (Republic) in 2007 and the Domestic credit (% of GDP) of Tanzania in 2008?
Keep it short and to the point. -9.89. What is the difference between the Domestic credit (% of GDP) in Latin America(all income levels) in 2007 and the Domestic credit (% of GDP) in Algeria in 2009?
Offer a terse response. 18.9. What is the difference between the Domestic credit (% of GDP) of Latin America(all income levels) in 2007 and the Domestic credit (% of GDP) of Congo (Republic) in 2009?
Ensure brevity in your answer.  30.25. What is the difference between the Domestic credit (% of GDP) in Latin America(all income levels) in 2007 and the Domestic credit (% of GDP) in Tanzania in 2009?
Offer a terse response. 23.7. What is the difference between the Domestic credit (% of GDP) in Algeria in 2007 and the Domestic credit (% of GDP) in Congo (Republic) in 2009?
Keep it short and to the point. 8.07. What is the difference between the Domestic credit (% of GDP) in Algeria in 2007 and the Domestic credit (% of GDP) in Tanzania in 2009?
Your answer should be compact. 1.52. What is the difference between the Domestic credit (% of GDP) of Congo (Republic) in 2007 and the Domestic credit (% of GDP) of Tanzania in 2009?
Offer a terse response. -9.2. What is the difference between the Domestic credit (% of GDP) in Latin America(all income levels) in 2008 and the Domestic credit (% of GDP) in Algeria in 2009?
Offer a terse response. 21.67. What is the difference between the Domestic credit (% of GDP) in Latin America(all income levels) in 2008 and the Domestic credit (% of GDP) in Congo (Republic) in 2009?
Provide a succinct answer. 33.02. What is the difference between the Domestic credit (% of GDP) in Latin America(all income levels) in 2008 and the Domestic credit (% of GDP) in Tanzania in 2009?
Give a very brief answer. 26.47. What is the difference between the Domestic credit (% of GDP) in Algeria in 2008 and the Domestic credit (% of GDP) in Congo (Republic) in 2009?
Keep it short and to the point. 7.88. What is the difference between the Domestic credit (% of GDP) in Algeria in 2008 and the Domestic credit (% of GDP) in Tanzania in 2009?
Your answer should be very brief. 1.33. What is the difference between the Domestic credit (% of GDP) of Congo (Republic) in 2008 and the Domestic credit (% of GDP) of Tanzania in 2009?
Provide a short and direct response. -8.32. What is the average Domestic credit (% of GDP) in Latin America(all income levels) per year?
Your answer should be very brief. 30.79. What is the average Domestic credit (% of GDP) of Algeria per year?
Keep it short and to the point. 12.56. What is the average Domestic credit (% of GDP) of Congo (Republic) per year?
Your response must be concise. 3.03. What is the average Domestic credit (% of GDP) of Tanzania per year?
Your answer should be very brief. 9.72. In the year 2002, what is the difference between the Domestic credit (% of GDP) in Latin America(all income levels) and Domestic credit (% of GDP) in Algeria?
Provide a succinct answer. 12.58. In the year 2002, what is the difference between the Domestic credit (% of GDP) in Latin America(all income levels) and Domestic credit (% of GDP) in Congo (Republic)?
Ensure brevity in your answer.  21.91. In the year 2002, what is the difference between the Domestic credit (% of GDP) in Latin America(all income levels) and Domestic credit (% of GDP) in Tanzania?
Offer a very short reply. 17.94. In the year 2002, what is the difference between the Domestic credit (% of GDP) of Algeria and Domestic credit (% of GDP) of Congo (Republic)?
Ensure brevity in your answer.  9.33. In the year 2002, what is the difference between the Domestic credit (% of GDP) of Algeria and Domestic credit (% of GDP) of Tanzania?
Ensure brevity in your answer.  5.37. In the year 2002, what is the difference between the Domestic credit (% of GDP) of Congo (Republic) and Domestic credit (% of GDP) of Tanzania?
Provide a short and direct response. -3.97. In the year 2003, what is the difference between the Domestic credit (% of GDP) of Latin America(all income levels) and Domestic credit (% of GDP) of Algeria?
Offer a terse response. 13.37. In the year 2003, what is the difference between the Domestic credit (% of GDP) in Latin America(all income levels) and Domestic credit (% of GDP) in Congo (Republic)?
Your answer should be very brief. 20.95. In the year 2003, what is the difference between the Domestic credit (% of GDP) of Latin America(all income levels) and Domestic credit (% of GDP) of Tanzania?
Ensure brevity in your answer.  16.51. In the year 2003, what is the difference between the Domestic credit (% of GDP) of Algeria and Domestic credit (% of GDP) of Congo (Republic)?
Provide a succinct answer. 7.59. In the year 2003, what is the difference between the Domestic credit (% of GDP) of Algeria and Domestic credit (% of GDP) of Tanzania?
Your answer should be compact. 3.14. In the year 2003, what is the difference between the Domestic credit (% of GDP) of Congo (Republic) and Domestic credit (% of GDP) of Tanzania?
Your answer should be very brief. -4.45. In the year 2004, what is the difference between the Domestic credit (% of GDP) of Latin America(all income levels) and Domestic credit (% of GDP) of Algeria?
Provide a short and direct response. 14.28. In the year 2004, what is the difference between the Domestic credit (% of GDP) of Latin America(all income levels) and Domestic credit (% of GDP) of Congo (Republic)?
Offer a very short reply. 22.35. In the year 2004, what is the difference between the Domestic credit (% of GDP) of Latin America(all income levels) and Domestic credit (% of GDP) of Tanzania?
Your response must be concise. 16.04. In the year 2004, what is the difference between the Domestic credit (% of GDP) in Algeria and Domestic credit (% of GDP) in Congo (Republic)?
Ensure brevity in your answer.  8.07. In the year 2004, what is the difference between the Domestic credit (% of GDP) in Algeria and Domestic credit (% of GDP) in Tanzania?
Keep it short and to the point. 1.76. In the year 2004, what is the difference between the Domestic credit (% of GDP) in Congo (Republic) and Domestic credit (% of GDP) in Tanzania?
Make the answer very short. -6.31. In the year 2005, what is the difference between the Domestic credit (% of GDP) in Latin America(all income levels) and Domestic credit (% of GDP) in Algeria?
Offer a very short reply. 15.36. In the year 2005, what is the difference between the Domestic credit (% of GDP) in Latin America(all income levels) and Domestic credit (% of GDP) in Congo (Republic)?
Offer a very short reply. 24.87. In the year 2005, what is the difference between the Domestic credit (% of GDP) in Latin America(all income levels) and Domestic credit (% of GDP) in Tanzania?
Make the answer very short. 18.78. In the year 2005, what is the difference between the Domestic credit (% of GDP) in Algeria and Domestic credit (% of GDP) in Congo (Republic)?
Offer a very short reply. 9.52. In the year 2005, what is the difference between the Domestic credit (% of GDP) of Algeria and Domestic credit (% of GDP) of Tanzania?
Offer a very short reply. 3.42. In the year 2005, what is the difference between the Domestic credit (% of GDP) in Congo (Republic) and Domestic credit (% of GDP) in Tanzania?
Provide a succinct answer. -6.09. In the year 2006, what is the difference between the Domestic credit (% of GDP) in Latin America(all income levels) and Domestic credit (% of GDP) in Algeria?
Provide a short and direct response. 18.69. In the year 2006, what is the difference between the Domestic credit (% of GDP) in Latin America(all income levels) and Domestic credit (% of GDP) in Congo (Republic)?
Offer a terse response. 28.71. In the year 2006, what is the difference between the Domestic credit (% of GDP) in Latin America(all income levels) and Domestic credit (% of GDP) in Tanzania?
Ensure brevity in your answer.  21. In the year 2006, what is the difference between the Domestic credit (% of GDP) of Algeria and Domestic credit (% of GDP) of Congo (Republic)?
Make the answer very short. 10.02. In the year 2006, what is the difference between the Domestic credit (% of GDP) of Algeria and Domestic credit (% of GDP) of Tanzania?
Your answer should be compact. 2.31. In the year 2006, what is the difference between the Domestic credit (% of GDP) of Congo (Republic) and Domestic credit (% of GDP) of Tanzania?
Ensure brevity in your answer.  -7.71. In the year 2007, what is the difference between the Domestic credit (% of GDP) of Latin America(all income levels) and Domestic credit (% of GDP) of Algeria?
Ensure brevity in your answer.  22.17. In the year 2007, what is the difference between the Domestic credit (% of GDP) of Latin America(all income levels) and Domestic credit (% of GDP) of Congo (Republic)?
Your answer should be very brief. 32.9. In the year 2007, what is the difference between the Domestic credit (% of GDP) in Latin America(all income levels) and Domestic credit (% of GDP) in Tanzania?
Provide a short and direct response. 23.51. In the year 2007, what is the difference between the Domestic credit (% of GDP) in Algeria and Domestic credit (% of GDP) in Congo (Republic)?
Offer a terse response. 10.72. In the year 2007, what is the difference between the Domestic credit (% of GDP) of Algeria and Domestic credit (% of GDP) of Tanzania?
Provide a succinct answer. 1.34. In the year 2007, what is the difference between the Domestic credit (% of GDP) in Congo (Republic) and Domestic credit (% of GDP) in Tanzania?
Your response must be concise. -9.38. In the year 2008, what is the difference between the Domestic credit (% of GDP) of Latin America(all income levels) and Domestic credit (% of GDP) of Algeria?
Offer a terse response. 25.14. In the year 2008, what is the difference between the Domestic credit (% of GDP) in Latin America(all income levels) and Domestic credit (% of GDP) in Congo (Republic)?
Give a very brief answer. 34.79. In the year 2008, what is the difference between the Domestic credit (% of GDP) of Latin America(all income levels) and Domestic credit (% of GDP) of Tanzania?
Your answer should be very brief. 25.78. In the year 2008, what is the difference between the Domestic credit (% of GDP) in Algeria and Domestic credit (% of GDP) in Congo (Republic)?
Your answer should be compact. 9.65. In the year 2008, what is the difference between the Domestic credit (% of GDP) of Algeria and Domestic credit (% of GDP) of Tanzania?
Provide a short and direct response. 0.64. In the year 2008, what is the difference between the Domestic credit (% of GDP) of Congo (Republic) and Domestic credit (% of GDP) of Tanzania?
Give a very brief answer. -9.02. In the year 2009, what is the difference between the Domestic credit (% of GDP) in Latin America(all income levels) and Domestic credit (% of GDP) in Algeria?
Keep it short and to the point. 24.2. In the year 2009, what is the difference between the Domestic credit (% of GDP) in Latin America(all income levels) and Domestic credit (% of GDP) in Congo (Republic)?
Your response must be concise. 35.54. In the year 2009, what is the difference between the Domestic credit (% of GDP) in Latin America(all income levels) and Domestic credit (% of GDP) in Tanzania?
Give a very brief answer. 28.99. In the year 2009, what is the difference between the Domestic credit (% of GDP) in Algeria and Domestic credit (% of GDP) in Congo (Republic)?
Make the answer very short. 11.35. In the year 2009, what is the difference between the Domestic credit (% of GDP) of Algeria and Domestic credit (% of GDP) of Tanzania?
Make the answer very short. 4.8. In the year 2009, what is the difference between the Domestic credit (% of GDP) in Congo (Republic) and Domestic credit (% of GDP) in Tanzania?
Offer a very short reply. -6.55. What is the ratio of the Domestic credit (% of GDP) in Latin America(all income levels) in 2002 to that in 2003?
Ensure brevity in your answer.  1.01. What is the ratio of the Domestic credit (% of GDP) in Algeria in 2002 to that in 2003?
Ensure brevity in your answer.  1.09. What is the ratio of the Domestic credit (% of GDP) in Congo (Republic) in 2002 to that in 2003?
Provide a succinct answer. 0.79. What is the ratio of the Domestic credit (% of GDP) of Tanzania in 2002 to that in 2003?
Keep it short and to the point. 0.85. What is the ratio of the Domestic credit (% of GDP) of Latin America(all income levels) in 2002 to that in 2004?
Ensure brevity in your answer.  0.98. What is the ratio of the Domestic credit (% of GDP) of Algeria in 2002 to that in 2004?
Keep it short and to the point. 1.11. What is the ratio of the Domestic credit (% of GDP) in Congo (Republic) in 2002 to that in 2004?
Keep it short and to the point. 0.98. What is the ratio of the Domestic credit (% of GDP) in Tanzania in 2002 to that in 2004?
Ensure brevity in your answer.  0.74. What is the ratio of the Domestic credit (% of GDP) in Latin America(all income levels) in 2002 to that in 2005?
Your answer should be compact. 0.91. What is the ratio of the Domestic credit (% of GDP) of Algeria in 2002 to that in 2005?
Your answer should be compact. 1.02. What is the ratio of the Domestic credit (% of GDP) of Congo (Republic) in 2002 to that in 2005?
Offer a very short reply. 1.19. What is the ratio of the Domestic credit (% of GDP) of Tanzania in 2002 to that in 2005?
Your answer should be very brief. 0.8. What is the ratio of the Domestic credit (% of GDP) of Latin America(all income levels) in 2002 to that in 2006?
Provide a short and direct response. 0.8. What is the ratio of the Domestic credit (% of GDP) in Algeria in 2002 to that in 2006?
Give a very brief answer. 1.01. What is the ratio of the Domestic credit (% of GDP) of Congo (Republic) in 2002 to that in 2006?
Offer a very short reply. 1.37. What is the ratio of the Domestic credit (% of GDP) in Tanzania in 2002 to that in 2006?
Ensure brevity in your answer.  0.7. What is the ratio of the Domestic credit (% of GDP) of Latin America(all income levels) in 2002 to that in 2007?
Ensure brevity in your answer.  0.7. What is the ratio of the Domestic credit (% of GDP) of Algeria in 2002 to that in 2007?
Your answer should be very brief. 0.94. What is the ratio of the Domestic credit (% of GDP) in Congo (Republic) in 2002 to that in 2007?
Offer a very short reply. 1.26. What is the ratio of the Domestic credit (% of GDP) in Tanzania in 2002 to that in 2007?
Give a very brief answer. 0.59. What is the ratio of the Domestic credit (% of GDP) of Latin America(all income levels) in 2002 to that in 2008?
Your response must be concise. 0.65. What is the ratio of the Domestic credit (% of GDP) of Algeria in 2002 to that in 2008?
Keep it short and to the point. 0.95. What is the ratio of the Domestic credit (% of GDP) of Congo (Republic) in 2002 to that in 2008?
Offer a very short reply. 0.91. What is the ratio of the Domestic credit (% of GDP) of Tanzania in 2002 to that in 2008?
Provide a succinct answer. 0.56. What is the ratio of the Domestic credit (% of GDP) of Latin America(all income levels) in 2002 to that in 2009?
Make the answer very short. 0.61. What is the ratio of the Domestic credit (% of GDP) in Algeria in 2002 to that in 2009?
Keep it short and to the point. 0.75. What is the ratio of the Domestic credit (% of GDP) of Congo (Republic) in 2002 to that in 2009?
Your answer should be very brief. 0.58. What is the ratio of the Domestic credit (% of GDP) of Tanzania in 2002 to that in 2009?
Offer a terse response. 0.6. What is the ratio of the Domestic credit (% of GDP) in Latin America(all income levels) in 2003 to that in 2004?
Ensure brevity in your answer.  0.97. What is the ratio of the Domestic credit (% of GDP) in Algeria in 2003 to that in 2004?
Offer a very short reply. 1.02. What is the ratio of the Domestic credit (% of GDP) of Congo (Republic) in 2003 to that in 2004?
Offer a very short reply. 1.24. What is the ratio of the Domestic credit (% of GDP) of Tanzania in 2003 to that in 2004?
Your response must be concise. 0.87. What is the ratio of the Domestic credit (% of GDP) in Latin America(all income levels) in 2003 to that in 2005?
Provide a short and direct response. 0.9. What is the ratio of the Domestic credit (% of GDP) in Algeria in 2003 to that in 2005?
Your response must be concise. 0.94. What is the ratio of the Domestic credit (% of GDP) in Congo (Republic) in 2003 to that in 2005?
Ensure brevity in your answer.  1.51. What is the ratio of the Domestic credit (% of GDP) of Tanzania in 2003 to that in 2005?
Offer a terse response. 0.95. What is the ratio of the Domestic credit (% of GDP) of Latin America(all income levels) in 2003 to that in 2006?
Your answer should be very brief. 0.8. What is the ratio of the Domestic credit (% of GDP) in Algeria in 2003 to that in 2006?
Make the answer very short. 0.93. What is the ratio of the Domestic credit (% of GDP) in Congo (Republic) in 2003 to that in 2006?
Offer a terse response. 1.73. What is the ratio of the Domestic credit (% of GDP) in Tanzania in 2003 to that in 2006?
Offer a very short reply. 0.82. What is the ratio of the Domestic credit (% of GDP) of Latin America(all income levels) in 2003 to that in 2007?
Give a very brief answer. 0.7. What is the ratio of the Domestic credit (% of GDP) in Algeria in 2003 to that in 2007?
Keep it short and to the point. 0.86. What is the ratio of the Domestic credit (% of GDP) of Congo (Republic) in 2003 to that in 2007?
Provide a succinct answer. 1.6. What is the ratio of the Domestic credit (% of GDP) in Tanzania in 2003 to that in 2007?
Give a very brief answer. 0.69. What is the ratio of the Domestic credit (% of GDP) of Latin America(all income levels) in 2003 to that in 2008?
Your response must be concise. 0.65. What is the ratio of the Domestic credit (% of GDP) of Algeria in 2003 to that in 2008?
Provide a succinct answer. 0.88. What is the ratio of the Domestic credit (% of GDP) in Congo (Republic) in 2003 to that in 2008?
Your answer should be compact. 1.16. What is the ratio of the Domestic credit (% of GDP) of Tanzania in 2003 to that in 2008?
Your answer should be very brief. 0.66. What is the ratio of the Domestic credit (% of GDP) in Latin America(all income levels) in 2003 to that in 2009?
Provide a short and direct response. 0.61. What is the ratio of the Domestic credit (% of GDP) in Algeria in 2003 to that in 2009?
Your answer should be compact. 0.69. What is the ratio of the Domestic credit (% of GDP) in Congo (Republic) in 2003 to that in 2009?
Your response must be concise. 0.74. What is the ratio of the Domestic credit (% of GDP) of Tanzania in 2003 to that in 2009?
Your answer should be very brief. 0.7. What is the ratio of the Domestic credit (% of GDP) of Latin America(all income levels) in 2004 to that in 2005?
Provide a succinct answer. 0.93. What is the ratio of the Domestic credit (% of GDP) in Algeria in 2004 to that in 2005?
Your answer should be very brief. 0.92. What is the ratio of the Domestic credit (% of GDP) of Congo (Republic) in 2004 to that in 2005?
Your answer should be very brief. 1.21. What is the ratio of the Domestic credit (% of GDP) of Tanzania in 2004 to that in 2005?
Your answer should be very brief. 1.09. What is the ratio of the Domestic credit (% of GDP) of Latin America(all income levels) in 2004 to that in 2006?
Your response must be concise. 0.82. What is the ratio of the Domestic credit (% of GDP) in Algeria in 2004 to that in 2006?
Offer a very short reply. 0.91. What is the ratio of the Domestic credit (% of GDP) in Congo (Republic) in 2004 to that in 2006?
Provide a short and direct response. 1.4. What is the ratio of the Domestic credit (% of GDP) in Tanzania in 2004 to that in 2006?
Give a very brief answer. 0.94. What is the ratio of the Domestic credit (% of GDP) in Latin America(all income levels) in 2004 to that in 2007?
Provide a short and direct response. 0.72. What is the ratio of the Domestic credit (% of GDP) of Algeria in 2004 to that in 2007?
Your answer should be very brief. 0.85. What is the ratio of the Domestic credit (% of GDP) in Congo (Republic) in 2004 to that in 2007?
Provide a short and direct response. 1.29. What is the ratio of the Domestic credit (% of GDP) of Tanzania in 2004 to that in 2007?
Make the answer very short. 0.79. What is the ratio of the Domestic credit (% of GDP) in Latin America(all income levels) in 2004 to that in 2008?
Provide a succinct answer. 0.67. What is the ratio of the Domestic credit (% of GDP) of Algeria in 2004 to that in 2008?
Offer a terse response. 0.86. What is the ratio of the Domestic credit (% of GDP) of Congo (Republic) in 2004 to that in 2008?
Your response must be concise. 0.93. What is the ratio of the Domestic credit (% of GDP) in Tanzania in 2004 to that in 2008?
Ensure brevity in your answer.  0.76. What is the ratio of the Domestic credit (% of GDP) in Latin America(all income levels) in 2004 to that in 2009?
Offer a very short reply. 0.62. What is the ratio of the Domestic credit (% of GDP) of Algeria in 2004 to that in 2009?
Ensure brevity in your answer.  0.68. What is the ratio of the Domestic credit (% of GDP) of Congo (Republic) in 2004 to that in 2009?
Your answer should be compact. 0.6. What is the ratio of the Domestic credit (% of GDP) in Tanzania in 2004 to that in 2009?
Ensure brevity in your answer.  0.81. What is the ratio of the Domestic credit (% of GDP) of Latin America(all income levels) in 2005 to that in 2006?
Offer a very short reply. 0.89. What is the ratio of the Domestic credit (% of GDP) of Algeria in 2005 to that in 2006?
Keep it short and to the point. 0.98. What is the ratio of the Domestic credit (% of GDP) in Congo (Republic) in 2005 to that in 2006?
Offer a very short reply. 1.15. What is the ratio of the Domestic credit (% of GDP) in Tanzania in 2005 to that in 2006?
Offer a terse response. 0.87. What is the ratio of the Domestic credit (% of GDP) of Latin America(all income levels) in 2005 to that in 2007?
Ensure brevity in your answer.  0.78. What is the ratio of the Domestic credit (% of GDP) of Algeria in 2005 to that in 2007?
Your response must be concise. 0.92. What is the ratio of the Domestic credit (% of GDP) in Congo (Republic) in 2005 to that in 2007?
Provide a succinct answer. 1.06. What is the ratio of the Domestic credit (% of GDP) of Tanzania in 2005 to that in 2007?
Make the answer very short. 0.73. What is the ratio of the Domestic credit (% of GDP) in Latin America(all income levels) in 2005 to that in 2008?
Your answer should be very brief. 0.72. What is the ratio of the Domestic credit (% of GDP) in Algeria in 2005 to that in 2008?
Keep it short and to the point. 0.93. What is the ratio of the Domestic credit (% of GDP) of Congo (Republic) in 2005 to that in 2008?
Give a very brief answer. 0.77. What is the ratio of the Domestic credit (% of GDP) in Tanzania in 2005 to that in 2008?
Provide a succinct answer. 0.7. What is the ratio of the Domestic credit (% of GDP) in Latin America(all income levels) in 2005 to that in 2009?
Your answer should be very brief. 0.67. What is the ratio of the Domestic credit (% of GDP) of Algeria in 2005 to that in 2009?
Give a very brief answer. 0.73. What is the ratio of the Domestic credit (% of GDP) of Congo (Republic) in 2005 to that in 2009?
Offer a very short reply. 0.49. What is the ratio of the Domestic credit (% of GDP) of Tanzania in 2005 to that in 2009?
Your answer should be very brief. 0.74. What is the ratio of the Domestic credit (% of GDP) of Latin America(all income levels) in 2006 to that in 2007?
Offer a very short reply. 0.88. What is the ratio of the Domestic credit (% of GDP) of Algeria in 2006 to that in 2007?
Provide a succinct answer. 0.93. What is the ratio of the Domestic credit (% of GDP) in Congo (Republic) in 2006 to that in 2007?
Offer a terse response. 0.93. What is the ratio of the Domestic credit (% of GDP) of Tanzania in 2006 to that in 2007?
Make the answer very short. 0.84. What is the ratio of the Domestic credit (% of GDP) in Latin America(all income levels) in 2006 to that in 2008?
Give a very brief answer. 0.81. What is the ratio of the Domestic credit (% of GDP) in Algeria in 2006 to that in 2008?
Keep it short and to the point. 0.95. What is the ratio of the Domestic credit (% of GDP) in Congo (Republic) in 2006 to that in 2008?
Keep it short and to the point. 0.67. What is the ratio of the Domestic credit (% of GDP) of Tanzania in 2006 to that in 2008?
Give a very brief answer. 0.81. What is the ratio of the Domestic credit (% of GDP) of Latin America(all income levels) in 2006 to that in 2009?
Provide a succinct answer. 0.76. What is the ratio of the Domestic credit (% of GDP) of Algeria in 2006 to that in 2009?
Make the answer very short. 0.74. What is the ratio of the Domestic credit (% of GDP) of Congo (Republic) in 2006 to that in 2009?
Your answer should be compact. 0.43. What is the ratio of the Domestic credit (% of GDP) of Tanzania in 2006 to that in 2009?
Provide a succinct answer. 0.86. What is the ratio of the Domestic credit (% of GDP) of Latin America(all income levels) in 2007 to that in 2008?
Provide a short and direct response. 0.93. What is the ratio of the Domestic credit (% of GDP) in Algeria in 2007 to that in 2008?
Your answer should be very brief. 1.02. What is the ratio of the Domestic credit (% of GDP) in Congo (Republic) in 2007 to that in 2008?
Offer a terse response. 0.72. What is the ratio of the Domestic credit (% of GDP) in Tanzania in 2007 to that in 2008?
Offer a terse response. 0.96. What is the ratio of the Domestic credit (% of GDP) of Latin America(all income levels) in 2007 to that in 2009?
Ensure brevity in your answer.  0.87. What is the ratio of the Domestic credit (% of GDP) of Algeria in 2007 to that in 2009?
Keep it short and to the point. 0.8. What is the ratio of the Domestic credit (% of GDP) in Congo (Republic) in 2007 to that in 2009?
Your response must be concise. 0.46. What is the ratio of the Domestic credit (% of GDP) in Tanzania in 2007 to that in 2009?
Ensure brevity in your answer.  1.02. What is the ratio of the Domestic credit (% of GDP) of Latin America(all income levels) in 2008 to that in 2009?
Offer a very short reply. 0.94. What is the ratio of the Domestic credit (% of GDP) of Algeria in 2008 to that in 2009?
Offer a very short reply. 0.79. What is the ratio of the Domestic credit (% of GDP) in Congo (Republic) in 2008 to that in 2009?
Offer a very short reply. 0.64. What is the ratio of the Domestic credit (% of GDP) in Tanzania in 2008 to that in 2009?
Your answer should be compact. 1.06. What is the difference between the highest and the second highest Domestic credit (% of GDP) in Latin America(all income levels)?
Offer a terse response. 2.53. What is the difference between the highest and the second highest Domestic credit (% of GDP) of Algeria?
Your answer should be compact. 3.28. What is the difference between the highest and the second highest Domestic credit (% of GDP) of Congo (Republic)?
Offer a very short reply. 1.28. What is the difference between the highest and the second highest Domestic credit (% of GDP) in Tanzania?
Keep it short and to the point. 0.51. What is the difference between the highest and the lowest Domestic credit (% of GDP) in Latin America(all income levels)?
Provide a succinct answer. 15.87. What is the difference between the highest and the lowest Domestic credit (% of GDP) of Algeria?
Your answer should be very brief. 5.27. What is the difference between the highest and the lowest Domestic credit (% of GDP) of Congo (Republic)?
Your response must be concise. 2.82. What is the difference between the highest and the lowest Domestic credit (% of GDP) of Tanzania?
Make the answer very short. 5.33. 